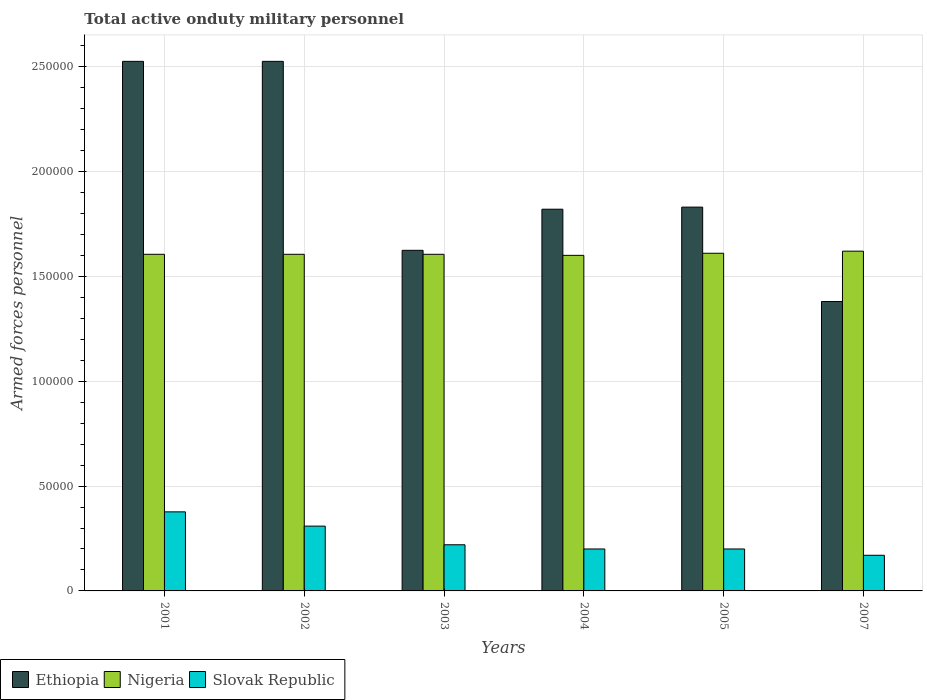Are the number of bars per tick equal to the number of legend labels?
Keep it short and to the point. Yes. What is the label of the 6th group of bars from the left?
Offer a terse response. 2007. What is the number of armed forces personnel in Nigeria in 2004?
Your answer should be compact. 1.60e+05. Across all years, what is the maximum number of armed forces personnel in Ethiopia?
Offer a terse response. 2.52e+05. Across all years, what is the minimum number of armed forces personnel in Nigeria?
Your answer should be very brief. 1.60e+05. In which year was the number of armed forces personnel in Ethiopia maximum?
Make the answer very short. 2001. In which year was the number of armed forces personnel in Ethiopia minimum?
Provide a short and direct response. 2007. What is the total number of armed forces personnel in Ethiopia in the graph?
Provide a short and direct response. 1.17e+06. What is the difference between the number of armed forces personnel in Nigeria in 2005 and that in 2007?
Provide a short and direct response. -1000. What is the difference between the number of armed forces personnel in Slovak Republic in 2003 and the number of armed forces personnel in Ethiopia in 2004?
Offer a very short reply. -1.60e+05. What is the average number of armed forces personnel in Nigeria per year?
Offer a very short reply. 1.61e+05. In the year 2003, what is the difference between the number of armed forces personnel in Nigeria and number of armed forces personnel in Ethiopia?
Keep it short and to the point. -1900. What is the ratio of the number of armed forces personnel in Nigeria in 2003 to that in 2005?
Offer a very short reply. 1. Is the number of armed forces personnel in Slovak Republic in 2001 less than that in 2003?
Your response must be concise. No. In how many years, is the number of armed forces personnel in Nigeria greater than the average number of armed forces personnel in Nigeria taken over all years?
Your answer should be compact. 2. What does the 3rd bar from the left in 2004 represents?
Give a very brief answer. Slovak Republic. What does the 3rd bar from the right in 2005 represents?
Provide a short and direct response. Ethiopia. Is it the case that in every year, the sum of the number of armed forces personnel in Nigeria and number of armed forces personnel in Ethiopia is greater than the number of armed forces personnel in Slovak Republic?
Provide a short and direct response. Yes. How many bars are there?
Your answer should be compact. 18. Are all the bars in the graph horizontal?
Provide a succinct answer. No. How many years are there in the graph?
Make the answer very short. 6. Does the graph contain any zero values?
Provide a succinct answer. No. Does the graph contain grids?
Ensure brevity in your answer.  Yes. Where does the legend appear in the graph?
Give a very brief answer. Bottom left. How are the legend labels stacked?
Your response must be concise. Horizontal. What is the title of the graph?
Ensure brevity in your answer.  Total active onduty military personnel. What is the label or title of the Y-axis?
Provide a succinct answer. Armed forces personnel. What is the Armed forces personnel of Ethiopia in 2001?
Your answer should be very brief. 2.52e+05. What is the Armed forces personnel of Nigeria in 2001?
Give a very brief answer. 1.60e+05. What is the Armed forces personnel in Slovak Republic in 2001?
Keep it short and to the point. 3.77e+04. What is the Armed forces personnel of Ethiopia in 2002?
Offer a very short reply. 2.52e+05. What is the Armed forces personnel in Nigeria in 2002?
Your answer should be very brief. 1.60e+05. What is the Armed forces personnel in Slovak Republic in 2002?
Give a very brief answer. 3.09e+04. What is the Armed forces personnel of Ethiopia in 2003?
Your response must be concise. 1.62e+05. What is the Armed forces personnel of Nigeria in 2003?
Your answer should be compact. 1.60e+05. What is the Armed forces personnel in Slovak Republic in 2003?
Give a very brief answer. 2.20e+04. What is the Armed forces personnel of Ethiopia in 2004?
Your answer should be compact. 1.82e+05. What is the Armed forces personnel of Nigeria in 2004?
Your answer should be compact. 1.60e+05. What is the Armed forces personnel of Slovak Republic in 2004?
Make the answer very short. 2.00e+04. What is the Armed forces personnel of Ethiopia in 2005?
Keep it short and to the point. 1.83e+05. What is the Armed forces personnel in Nigeria in 2005?
Give a very brief answer. 1.61e+05. What is the Armed forces personnel in Slovak Republic in 2005?
Your answer should be compact. 2.00e+04. What is the Armed forces personnel in Ethiopia in 2007?
Provide a succinct answer. 1.38e+05. What is the Armed forces personnel of Nigeria in 2007?
Provide a short and direct response. 1.62e+05. What is the Armed forces personnel of Slovak Republic in 2007?
Keep it short and to the point. 1.70e+04. Across all years, what is the maximum Armed forces personnel in Ethiopia?
Give a very brief answer. 2.52e+05. Across all years, what is the maximum Armed forces personnel in Nigeria?
Your answer should be very brief. 1.62e+05. Across all years, what is the maximum Armed forces personnel in Slovak Republic?
Provide a short and direct response. 3.77e+04. Across all years, what is the minimum Armed forces personnel in Ethiopia?
Your response must be concise. 1.38e+05. Across all years, what is the minimum Armed forces personnel of Nigeria?
Give a very brief answer. 1.60e+05. Across all years, what is the minimum Armed forces personnel in Slovak Republic?
Ensure brevity in your answer.  1.70e+04. What is the total Armed forces personnel in Ethiopia in the graph?
Your response must be concise. 1.17e+06. What is the total Armed forces personnel in Nigeria in the graph?
Offer a very short reply. 9.64e+05. What is the total Armed forces personnel of Slovak Republic in the graph?
Make the answer very short. 1.48e+05. What is the difference between the Armed forces personnel in Ethiopia in 2001 and that in 2002?
Give a very brief answer. 0. What is the difference between the Armed forces personnel of Slovak Republic in 2001 and that in 2002?
Keep it short and to the point. 6800. What is the difference between the Armed forces personnel of Ethiopia in 2001 and that in 2003?
Your response must be concise. 9.01e+04. What is the difference between the Armed forces personnel in Slovak Republic in 2001 and that in 2003?
Ensure brevity in your answer.  1.57e+04. What is the difference between the Armed forces personnel in Ethiopia in 2001 and that in 2004?
Offer a terse response. 7.05e+04. What is the difference between the Armed forces personnel in Slovak Republic in 2001 and that in 2004?
Your response must be concise. 1.77e+04. What is the difference between the Armed forces personnel of Ethiopia in 2001 and that in 2005?
Provide a succinct answer. 6.95e+04. What is the difference between the Armed forces personnel of Nigeria in 2001 and that in 2005?
Give a very brief answer. -500. What is the difference between the Armed forces personnel in Slovak Republic in 2001 and that in 2005?
Your answer should be very brief. 1.77e+04. What is the difference between the Armed forces personnel in Ethiopia in 2001 and that in 2007?
Your answer should be very brief. 1.14e+05. What is the difference between the Armed forces personnel of Nigeria in 2001 and that in 2007?
Your response must be concise. -1500. What is the difference between the Armed forces personnel in Slovak Republic in 2001 and that in 2007?
Your answer should be compact. 2.07e+04. What is the difference between the Armed forces personnel in Ethiopia in 2002 and that in 2003?
Give a very brief answer. 9.01e+04. What is the difference between the Armed forces personnel of Nigeria in 2002 and that in 2003?
Offer a very short reply. 0. What is the difference between the Armed forces personnel of Slovak Republic in 2002 and that in 2003?
Your answer should be very brief. 8900. What is the difference between the Armed forces personnel in Ethiopia in 2002 and that in 2004?
Provide a short and direct response. 7.05e+04. What is the difference between the Armed forces personnel of Slovak Republic in 2002 and that in 2004?
Your answer should be compact. 1.09e+04. What is the difference between the Armed forces personnel in Ethiopia in 2002 and that in 2005?
Provide a succinct answer. 6.95e+04. What is the difference between the Armed forces personnel in Nigeria in 2002 and that in 2005?
Provide a succinct answer. -500. What is the difference between the Armed forces personnel in Slovak Republic in 2002 and that in 2005?
Give a very brief answer. 1.09e+04. What is the difference between the Armed forces personnel in Ethiopia in 2002 and that in 2007?
Ensure brevity in your answer.  1.14e+05. What is the difference between the Armed forces personnel of Nigeria in 2002 and that in 2007?
Give a very brief answer. -1500. What is the difference between the Armed forces personnel of Slovak Republic in 2002 and that in 2007?
Ensure brevity in your answer.  1.39e+04. What is the difference between the Armed forces personnel of Ethiopia in 2003 and that in 2004?
Provide a short and direct response. -1.96e+04. What is the difference between the Armed forces personnel in Nigeria in 2003 and that in 2004?
Make the answer very short. 500. What is the difference between the Armed forces personnel in Ethiopia in 2003 and that in 2005?
Keep it short and to the point. -2.06e+04. What is the difference between the Armed forces personnel in Nigeria in 2003 and that in 2005?
Make the answer very short. -500. What is the difference between the Armed forces personnel of Ethiopia in 2003 and that in 2007?
Keep it short and to the point. 2.44e+04. What is the difference between the Armed forces personnel in Nigeria in 2003 and that in 2007?
Your answer should be very brief. -1500. What is the difference between the Armed forces personnel of Ethiopia in 2004 and that in 2005?
Give a very brief answer. -1000. What is the difference between the Armed forces personnel of Nigeria in 2004 and that in 2005?
Keep it short and to the point. -1000. What is the difference between the Armed forces personnel of Ethiopia in 2004 and that in 2007?
Make the answer very short. 4.40e+04. What is the difference between the Armed forces personnel in Nigeria in 2004 and that in 2007?
Give a very brief answer. -2000. What is the difference between the Armed forces personnel in Slovak Republic in 2004 and that in 2007?
Keep it short and to the point. 3000. What is the difference between the Armed forces personnel of Ethiopia in 2005 and that in 2007?
Offer a terse response. 4.50e+04. What is the difference between the Armed forces personnel of Nigeria in 2005 and that in 2007?
Provide a succinct answer. -1000. What is the difference between the Armed forces personnel in Slovak Republic in 2005 and that in 2007?
Provide a short and direct response. 3000. What is the difference between the Armed forces personnel in Ethiopia in 2001 and the Armed forces personnel in Nigeria in 2002?
Keep it short and to the point. 9.20e+04. What is the difference between the Armed forces personnel of Ethiopia in 2001 and the Armed forces personnel of Slovak Republic in 2002?
Your answer should be compact. 2.22e+05. What is the difference between the Armed forces personnel in Nigeria in 2001 and the Armed forces personnel in Slovak Republic in 2002?
Ensure brevity in your answer.  1.30e+05. What is the difference between the Armed forces personnel in Ethiopia in 2001 and the Armed forces personnel in Nigeria in 2003?
Offer a very short reply. 9.20e+04. What is the difference between the Armed forces personnel of Ethiopia in 2001 and the Armed forces personnel of Slovak Republic in 2003?
Keep it short and to the point. 2.30e+05. What is the difference between the Armed forces personnel in Nigeria in 2001 and the Armed forces personnel in Slovak Republic in 2003?
Ensure brevity in your answer.  1.38e+05. What is the difference between the Armed forces personnel of Ethiopia in 2001 and the Armed forces personnel of Nigeria in 2004?
Give a very brief answer. 9.25e+04. What is the difference between the Armed forces personnel of Ethiopia in 2001 and the Armed forces personnel of Slovak Republic in 2004?
Offer a terse response. 2.32e+05. What is the difference between the Armed forces personnel in Nigeria in 2001 and the Armed forces personnel in Slovak Republic in 2004?
Ensure brevity in your answer.  1.40e+05. What is the difference between the Armed forces personnel of Ethiopia in 2001 and the Armed forces personnel of Nigeria in 2005?
Offer a very short reply. 9.15e+04. What is the difference between the Armed forces personnel in Ethiopia in 2001 and the Armed forces personnel in Slovak Republic in 2005?
Make the answer very short. 2.32e+05. What is the difference between the Armed forces personnel in Nigeria in 2001 and the Armed forces personnel in Slovak Republic in 2005?
Ensure brevity in your answer.  1.40e+05. What is the difference between the Armed forces personnel of Ethiopia in 2001 and the Armed forces personnel of Nigeria in 2007?
Provide a short and direct response. 9.05e+04. What is the difference between the Armed forces personnel in Ethiopia in 2001 and the Armed forces personnel in Slovak Republic in 2007?
Ensure brevity in your answer.  2.36e+05. What is the difference between the Armed forces personnel in Nigeria in 2001 and the Armed forces personnel in Slovak Republic in 2007?
Make the answer very short. 1.44e+05. What is the difference between the Armed forces personnel in Ethiopia in 2002 and the Armed forces personnel in Nigeria in 2003?
Offer a terse response. 9.20e+04. What is the difference between the Armed forces personnel of Ethiopia in 2002 and the Armed forces personnel of Slovak Republic in 2003?
Your answer should be very brief. 2.30e+05. What is the difference between the Armed forces personnel in Nigeria in 2002 and the Armed forces personnel in Slovak Republic in 2003?
Ensure brevity in your answer.  1.38e+05. What is the difference between the Armed forces personnel in Ethiopia in 2002 and the Armed forces personnel in Nigeria in 2004?
Provide a short and direct response. 9.25e+04. What is the difference between the Armed forces personnel of Ethiopia in 2002 and the Armed forces personnel of Slovak Republic in 2004?
Keep it short and to the point. 2.32e+05. What is the difference between the Armed forces personnel in Nigeria in 2002 and the Armed forces personnel in Slovak Republic in 2004?
Offer a terse response. 1.40e+05. What is the difference between the Armed forces personnel of Ethiopia in 2002 and the Armed forces personnel of Nigeria in 2005?
Offer a terse response. 9.15e+04. What is the difference between the Armed forces personnel in Ethiopia in 2002 and the Armed forces personnel in Slovak Republic in 2005?
Offer a very short reply. 2.32e+05. What is the difference between the Armed forces personnel of Nigeria in 2002 and the Armed forces personnel of Slovak Republic in 2005?
Your answer should be very brief. 1.40e+05. What is the difference between the Armed forces personnel of Ethiopia in 2002 and the Armed forces personnel of Nigeria in 2007?
Make the answer very short. 9.05e+04. What is the difference between the Armed forces personnel of Ethiopia in 2002 and the Armed forces personnel of Slovak Republic in 2007?
Ensure brevity in your answer.  2.36e+05. What is the difference between the Armed forces personnel in Nigeria in 2002 and the Armed forces personnel in Slovak Republic in 2007?
Your answer should be very brief. 1.44e+05. What is the difference between the Armed forces personnel in Ethiopia in 2003 and the Armed forces personnel in Nigeria in 2004?
Your answer should be compact. 2400. What is the difference between the Armed forces personnel in Ethiopia in 2003 and the Armed forces personnel in Slovak Republic in 2004?
Provide a succinct answer. 1.42e+05. What is the difference between the Armed forces personnel in Nigeria in 2003 and the Armed forces personnel in Slovak Republic in 2004?
Provide a short and direct response. 1.40e+05. What is the difference between the Armed forces personnel of Ethiopia in 2003 and the Armed forces personnel of Nigeria in 2005?
Ensure brevity in your answer.  1400. What is the difference between the Armed forces personnel of Ethiopia in 2003 and the Armed forces personnel of Slovak Republic in 2005?
Your answer should be very brief. 1.42e+05. What is the difference between the Armed forces personnel of Nigeria in 2003 and the Armed forces personnel of Slovak Republic in 2005?
Your response must be concise. 1.40e+05. What is the difference between the Armed forces personnel of Ethiopia in 2003 and the Armed forces personnel of Nigeria in 2007?
Your answer should be compact. 400. What is the difference between the Armed forces personnel of Ethiopia in 2003 and the Armed forces personnel of Slovak Republic in 2007?
Provide a succinct answer. 1.45e+05. What is the difference between the Armed forces personnel of Nigeria in 2003 and the Armed forces personnel of Slovak Republic in 2007?
Make the answer very short. 1.44e+05. What is the difference between the Armed forces personnel in Ethiopia in 2004 and the Armed forces personnel in Nigeria in 2005?
Your answer should be compact. 2.10e+04. What is the difference between the Armed forces personnel of Ethiopia in 2004 and the Armed forces personnel of Slovak Republic in 2005?
Your response must be concise. 1.62e+05. What is the difference between the Armed forces personnel of Ethiopia in 2004 and the Armed forces personnel of Nigeria in 2007?
Your answer should be compact. 2.00e+04. What is the difference between the Armed forces personnel in Ethiopia in 2004 and the Armed forces personnel in Slovak Republic in 2007?
Offer a terse response. 1.65e+05. What is the difference between the Armed forces personnel of Nigeria in 2004 and the Armed forces personnel of Slovak Republic in 2007?
Offer a terse response. 1.43e+05. What is the difference between the Armed forces personnel of Ethiopia in 2005 and the Armed forces personnel of Nigeria in 2007?
Ensure brevity in your answer.  2.10e+04. What is the difference between the Armed forces personnel of Ethiopia in 2005 and the Armed forces personnel of Slovak Republic in 2007?
Your answer should be very brief. 1.66e+05. What is the difference between the Armed forces personnel in Nigeria in 2005 and the Armed forces personnel in Slovak Republic in 2007?
Ensure brevity in your answer.  1.44e+05. What is the average Armed forces personnel in Ethiopia per year?
Make the answer very short. 1.95e+05. What is the average Armed forces personnel in Nigeria per year?
Offer a very short reply. 1.61e+05. What is the average Armed forces personnel in Slovak Republic per year?
Keep it short and to the point. 2.46e+04. In the year 2001, what is the difference between the Armed forces personnel in Ethiopia and Armed forces personnel in Nigeria?
Offer a terse response. 9.20e+04. In the year 2001, what is the difference between the Armed forces personnel in Ethiopia and Armed forces personnel in Slovak Republic?
Offer a very short reply. 2.15e+05. In the year 2001, what is the difference between the Armed forces personnel in Nigeria and Armed forces personnel in Slovak Republic?
Offer a terse response. 1.23e+05. In the year 2002, what is the difference between the Armed forces personnel of Ethiopia and Armed forces personnel of Nigeria?
Your answer should be compact. 9.20e+04. In the year 2002, what is the difference between the Armed forces personnel in Ethiopia and Armed forces personnel in Slovak Republic?
Provide a succinct answer. 2.22e+05. In the year 2002, what is the difference between the Armed forces personnel of Nigeria and Armed forces personnel of Slovak Republic?
Provide a succinct answer. 1.30e+05. In the year 2003, what is the difference between the Armed forces personnel of Ethiopia and Armed forces personnel of Nigeria?
Offer a very short reply. 1900. In the year 2003, what is the difference between the Armed forces personnel of Ethiopia and Armed forces personnel of Slovak Republic?
Keep it short and to the point. 1.40e+05. In the year 2003, what is the difference between the Armed forces personnel of Nigeria and Armed forces personnel of Slovak Republic?
Ensure brevity in your answer.  1.38e+05. In the year 2004, what is the difference between the Armed forces personnel of Ethiopia and Armed forces personnel of Nigeria?
Your answer should be compact. 2.20e+04. In the year 2004, what is the difference between the Armed forces personnel in Ethiopia and Armed forces personnel in Slovak Republic?
Your answer should be compact. 1.62e+05. In the year 2005, what is the difference between the Armed forces personnel in Ethiopia and Armed forces personnel in Nigeria?
Keep it short and to the point. 2.20e+04. In the year 2005, what is the difference between the Armed forces personnel of Ethiopia and Armed forces personnel of Slovak Republic?
Offer a very short reply. 1.63e+05. In the year 2005, what is the difference between the Armed forces personnel in Nigeria and Armed forces personnel in Slovak Republic?
Keep it short and to the point. 1.41e+05. In the year 2007, what is the difference between the Armed forces personnel in Ethiopia and Armed forces personnel in Nigeria?
Keep it short and to the point. -2.40e+04. In the year 2007, what is the difference between the Armed forces personnel in Ethiopia and Armed forces personnel in Slovak Republic?
Ensure brevity in your answer.  1.21e+05. In the year 2007, what is the difference between the Armed forces personnel in Nigeria and Armed forces personnel in Slovak Republic?
Ensure brevity in your answer.  1.45e+05. What is the ratio of the Armed forces personnel in Ethiopia in 2001 to that in 2002?
Your answer should be compact. 1. What is the ratio of the Armed forces personnel of Nigeria in 2001 to that in 2002?
Offer a very short reply. 1. What is the ratio of the Armed forces personnel of Slovak Republic in 2001 to that in 2002?
Provide a succinct answer. 1.22. What is the ratio of the Armed forces personnel in Ethiopia in 2001 to that in 2003?
Ensure brevity in your answer.  1.55. What is the ratio of the Armed forces personnel in Nigeria in 2001 to that in 2003?
Keep it short and to the point. 1. What is the ratio of the Armed forces personnel of Slovak Republic in 2001 to that in 2003?
Provide a short and direct response. 1.71. What is the ratio of the Armed forces personnel of Ethiopia in 2001 to that in 2004?
Provide a succinct answer. 1.39. What is the ratio of the Armed forces personnel of Slovak Republic in 2001 to that in 2004?
Keep it short and to the point. 1.89. What is the ratio of the Armed forces personnel of Ethiopia in 2001 to that in 2005?
Provide a short and direct response. 1.38. What is the ratio of the Armed forces personnel in Nigeria in 2001 to that in 2005?
Provide a short and direct response. 1. What is the ratio of the Armed forces personnel in Slovak Republic in 2001 to that in 2005?
Your answer should be compact. 1.89. What is the ratio of the Armed forces personnel in Ethiopia in 2001 to that in 2007?
Make the answer very short. 1.83. What is the ratio of the Armed forces personnel in Slovak Republic in 2001 to that in 2007?
Make the answer very short. 2.22. What is the ratio of the Armed forces personnel of Ethiopia in 2002 to that in 2003?
Give a very brief answer. 1.55. What is the ratio of the Armed forces personnel in Slovak Republic in 2002 to that in 2003?
Keep it short and to the point. 1.4. What is the ratio of the Armed forces personnel in Ethiopia in 2002 to that in 2004?
Offer a terse response. 1.39. What is the ratio of the Armed forces personnel of Nigeria in 2002 to that in 2004?
Make the answer very short. 1. What is the ratio of the Armed forces personnel in Slovak Republic in 2002 to that in 2004?
Provide a short and direct response. 1.54. What is the ratio of the Armed forces personnel in Ethiopia in 2002 to that in 2005?
Your answer should be very brief. 1.38. What is the ratio of the Armed forces personnel in Nigeria in 2002 to that in 2005?
Offer a very short reply. 1. What is the ratio of the Armed forces personnel in Slovak Republic in 2002 to that in 2005?
Offer a terse response. 1.54. What is the ratio of the Armed forces personnel of Ethiopia in 2002 to that in 2007?
Your answer should be very brief. 1.83. What is the ratio of the Armed forces personnel of Nigeria in 2002 to that in 2007?
Keep it short and to the point. 0.99. What is the ratio of the Armed forces personnel in Slovak Republic in 2002 to that in 2007?
Provide a succinct answer. 1.82. What is the ratio of the Armed forces personnel in Ethiopia in 2003 to that in 2004?
Make the answer very short. 0.89. What is the ratio of the Armed forces personnel in Nigeria in 2003 to that in 2004?
Ensure brevity in your answer.  1. What is the ratio of the Armed forces personnel in Ethiopia in 2003 to that in 2005?
Your answer should be compact. 0.89. What is the ratio of the Armed forces personnel in Nigeria in 2003 to that in 2005?
Offer a very short reply. 1. What is the ratio of the Armed forces personnel of Slovak Republic in 2003 to that in 2005?
Provide a short and direct response. 1.1. What is the ratio of the Armed forces personnel of Ethiopia in 2003 to that in 2007?
Give a very brief answer. 1.18. What is the ratio of the Armed forces personnel of Nigeria in 2003 to that in 2007?
Provide a short and direct response. 0.99. What is the ratio of the Armed forces personnel in Slovak Republic in 2003 to that in 2007?
Make the answer very short. 1.29. What is the ratio of the Armed forces personnel of Nigeria in 2004 to that in 2005?
Make the answer very short. 0.99. What is the ratio of the Armed forces personnel in Slovak Republic in 2004 to that in 2005?
Make the answer very short. 1. What is the ratio of the Armed forces personnel in Ethiopia in 2004 to that in 2007?
Provide a succinct answer. 1.32. What is the ratio of the Armed forces personnel in Slovak Republic in 2004 to that in 2007?
Keep it short and to the point. 1.18. What is the ratio of the Armed forces personnel in Ethiopia in 2005 to that in 2007?
Your answer should be compact. 1.33. What is the ratio of the Armed forces personnel in Nigeria in 2005 to that in 2007?
Offer a very short reply. 0.99. What is the ratio of the Armed forces personnel in Slovak Republic in 2005 to that in 2007?
Provide a succinct answer. 1.18. What is the difference between the highest and the second highest Armed forces personnel of Nigeria?
Your response must be concise. 1000. What is the difference between the highest and the second highest Armed forces personnel of Slovak Republic?
Provide a short and direct response. 6800. What is the difference between the highest and the lowest Armed forces personnel in Ethiopia?
Your answer should be very brief. 1.14e+05. What is the difference between the highest and the lowest Armed forces personnel in Nigeria?
Give a very brief answer. 2000. What is the difference between the highest and the lowest Armed forces personnel in Slovak Republic?
Your answer should be very brief. 2.07e+04. 